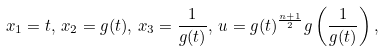<formula> <loc_0><loc_0><loc_500><loc_500>x _ { 1 } = t , \, x _ { 2 } = g ( t ) , \, x _ { 3 } = \frac { 1 } { g ( t ) } , \, u = g ( t ) ^ { \frac { n + 1 } { 2 } } g \left ( \frac { 1 } { g ( t ) } \right ) ,</formula> 